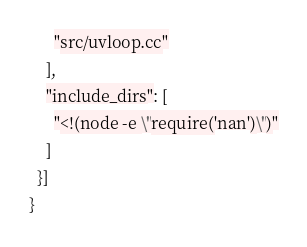Convert code to text. <code><loc_0><loc_0><loc_500><loc_500><_Python_>      "src/uvloop.cc"
    ],
    "include_dirs": [
      "<!(node -e \"require('nan')\")"
    ]
  }]
}
</code> 